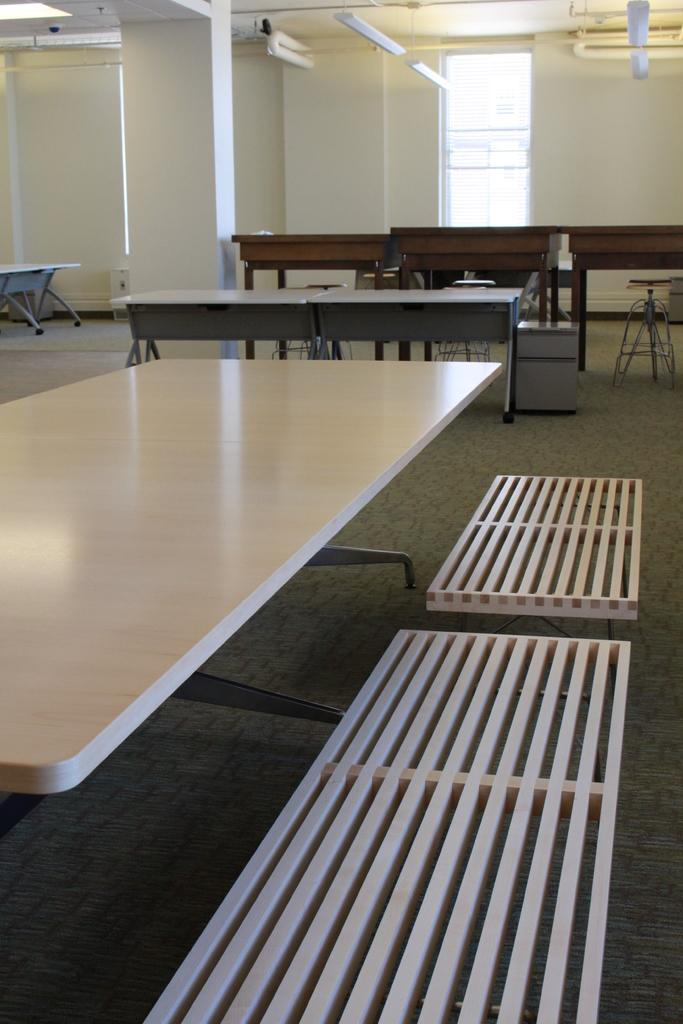What type of furniture is present in the image? There are tables and benches in the image. What can be seen illuminating the area in the image? There are lights in the image. Where is the image set? The image is set on a rooftop. What architectural feature is present in the image? There is a wall in the image. What allows for a view of the outside from within the image? There is a window in the image. Can you tell me the date of birth of the person sitting on the bench in the image? There is no person present in the image, so it is not possible to determine their date of birth. What type of breakfast is being served on the table in the image? There is no breakfast present in the image; only tables, benches, lights, a rooftop, wall, and a window are visible. 